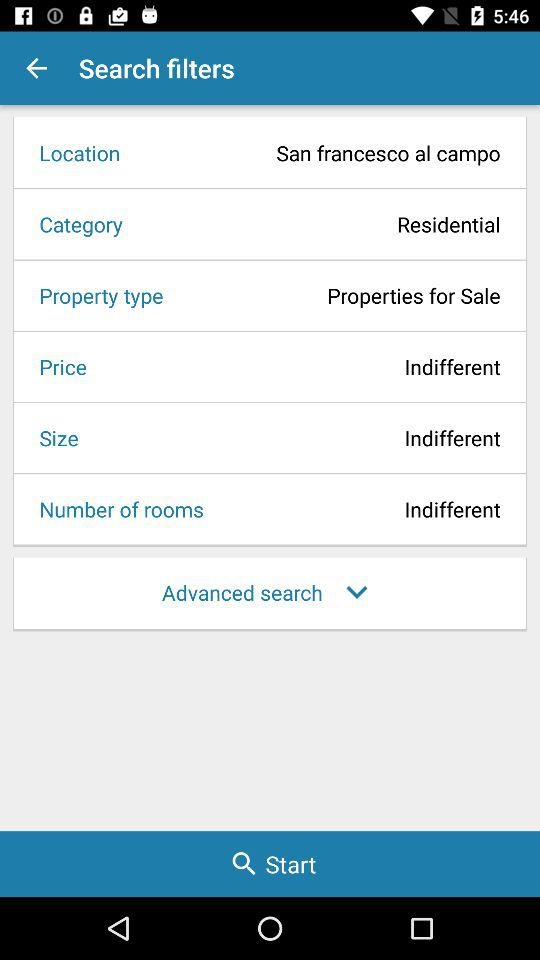What is the property type? The property type is "Properties for Sale". 